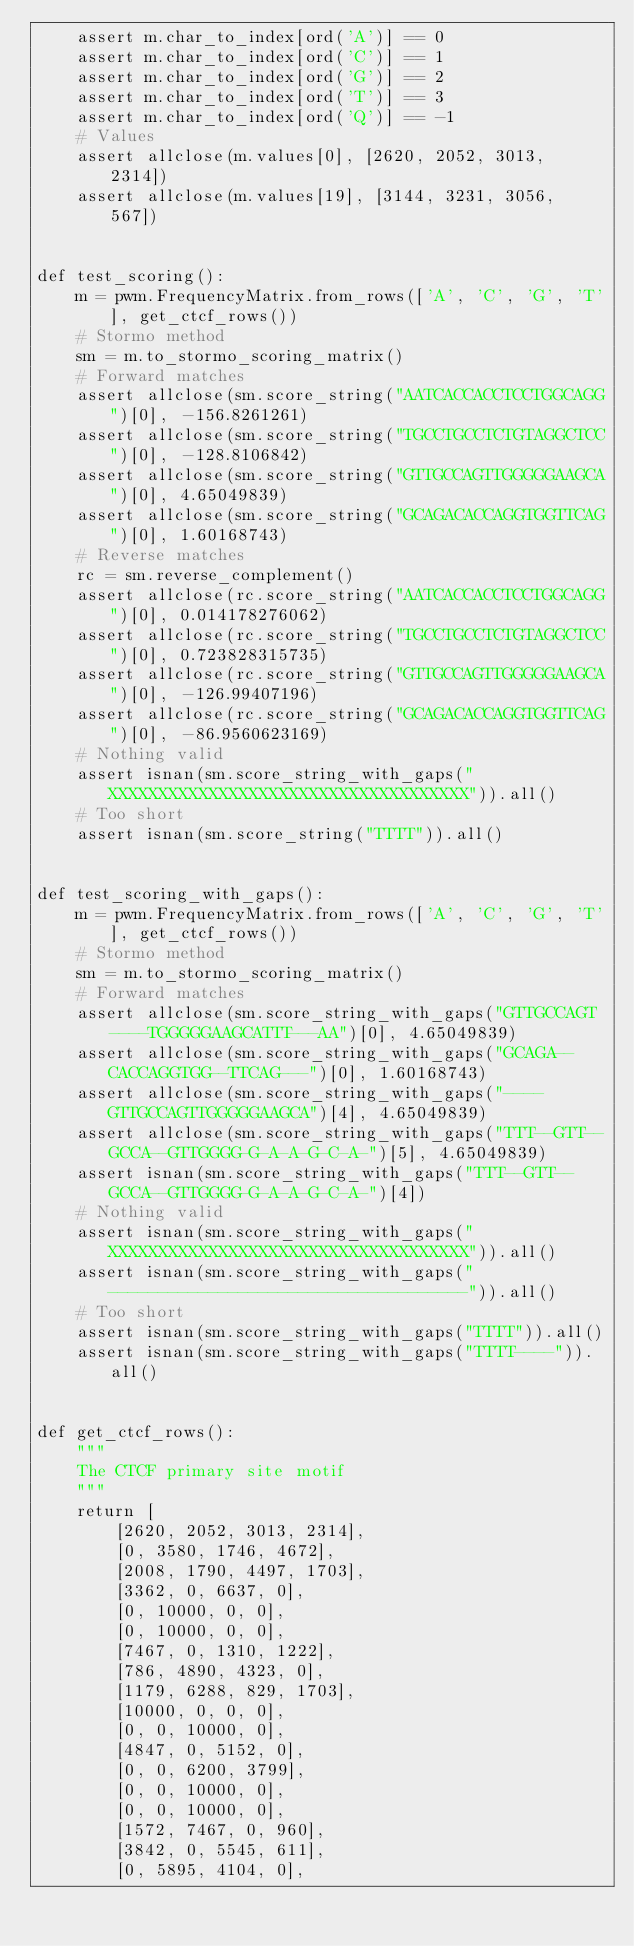Convert code to text. <code><loc_0><loc_0><loc_500><loc_500><_Python_>    assert m.char_to_index[ord('A')] == 0
    assert m.char_to_index[ord('C')] == 1
    assert m.char_to_index[ord('G')] == 2
    assert m.char_to_index[ord('T')] == 3
    assert m.char_to_index[ord('Q')] == -1
    # Values
    assert allclose(m.values[0], [2620, 2052, 3013, 2314])
    assert allclose(m.values[19], [3144, 3231, 3056, 567])


def test_scoring():
    m = pwm.FrequencyMatrix.from_rows(['A', 'C', 'G', 'T'], get_ctcf_rows())
    # Stormo method
    sm = m.to_stormo_scoring_matrix()
    # Forward matches
    assert allclose(sm.score_string("AATCACCACCTCCTGGCAGG")[0], -156.8261261)
    assert allclose(sm.score_string("TGCCTGCCTCTGTAGGCTCC")[0], -128.8106842)
    assert allclose(sm.score_string("GTTGCCAGTTGGGGGAAGCA")[0], 4.65049839)
    assert allclose(sm.score_string("GCAGACACCAGGTGGTTCAG")[0], 1.60168743)
    # Reverse matches
    rc = sm.reverse_complement()
    assert allclose(rc.score_string("AATCACCACCTCCTGGCAGG")[0], 0.014178276062)
    assert allclose(rc.score_string("TGCCTGCCTCTGTAGGCTCC")[0], 0.723828315735)
    assert allclose(rc.score_string("GTTGCCAGTTGGGGGAAGCA")[0], -126.99407196)
    assert allclose(rc.score_string("GCAGACACCAGGTGGTTCAG")[0], -86.9560623169)
    # Nothing valid
    assert isnan(sm.score_string_with_gaps("XXXXXXXXXXXXXXXXXXXXXXXXXXXXXXXXXXXX")).all()
    # Too short
    assert isnan(sm.score_string("TTTT")).all()


def test_scoring_with_gaps():
    m = pwm.FrequencyMatrix.from_rows(['A', 'C', 'G', 'T'], get_ctcf_rows())
    # Stormo method
    sm = m.to_stormo_scoring_matrix()
    # Forward matches
    assert allclose(sm.score_string_with_gaps("GTTGCCAGT----TGGGGGAAGCATTT---AA")[0], 4.65049839)
    assert allclose(sm.score_string_with_gaps("GCAGA--CACCAGGTGG--TTCAG---")[0], 1.60168743)
    assert allclose(sm.score_string_with_gaps("----GTTGCCAGTTGGGGGAAGCA")[4], 4.65049839)
    assert allclose(sm.score_string_with_gaps("TTT--GTT--GCCA--GTTGGGG-G-A-A-G-C-A-")[5], 4.65049839)
    assert isnan(sm.score_string_with_gaps("TTT--GTT--GCCA--GTTGGGG-G-A-A-G-C-A-")[4])
    # Nothing valid
    assert isnan(sm.score_string_with_gaps("XXXXXXXXXXXXXXXXXXXXXXXXXXXXXXXXXXXX")).all()
    assert isnan(sm.score_string_with_gaps("------------------------------------")).all()
    # Too short
    assert isnan(sm.score_string_with_gaps("TTTT")).all()
    assert isnan(sm.score_string_with_gaps("TTTT----")).all()


def get_ctcf_rows():
    """
    The CTCF primary site motif
    """
    return [
        [2620, 2052, 3013, 2314],
        [0, 3580, 1746, 4672],
        [2008, 1790, 4497, 1703],
        [3362, 0, 6637, 0],
        [0, 10000, 0, 0],
        [0, 10000, 0, 0],
        [7467, 0, 1310, 1222],
        [786, 4890, 4323, 0],
        [1179, 6288, 829, 1703],
        [10000, 0, 0, 0],
        [0, 0, 10000, 0],
        [4847, 0, 5152, 0],
        [0, 0, 6200, 3799],
        [0, 0, 10000, 0],
        [0, 0, 10000, 0],
        [1572, 7467, 0, 960],
        [3842, 0, 5545, 611],
        [0, 5895, 4104, 0],</code> 